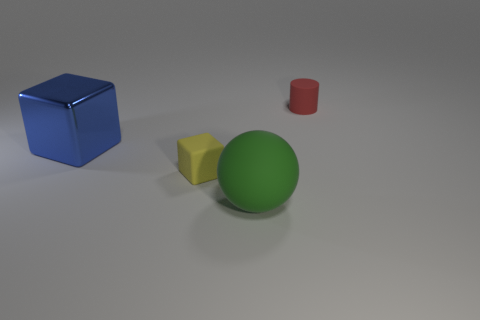Does the cylinder have the same size as the yellow rubber cube?
Provide a short and direct response. Yes. What material is the blue object?
Make the answer very short. Metal. There is another object that is the same size as the red matte thing; what material is it?
Offer a terse response. Rubber. Is there another cube of the same size as the blue block?
Keep it short and to the point. No. Are there the same number of tiny cylinders to the left of the large green object and green balls that are to the left of the blue metallic block?
Offer a very short reply. Yes. Are there more big matte objects than big brown rubber things?
Ensure brevity in your answer.  Yes. How many metallic things are either green objects or yellow objects?
Your response must be concise. 0. What is the material of the big thing to the left of the matte thing that is in front of the cube in front of the large blue thing?
Give a very brief answer. Metal. There is a small rubber thing in front of the matte thing that is behind the rubber cube; what color is it?
Your answer should be compact. Yellow. What number of large things are either matte cylinders or shiny blocks?
Offer a terse response. 1. 